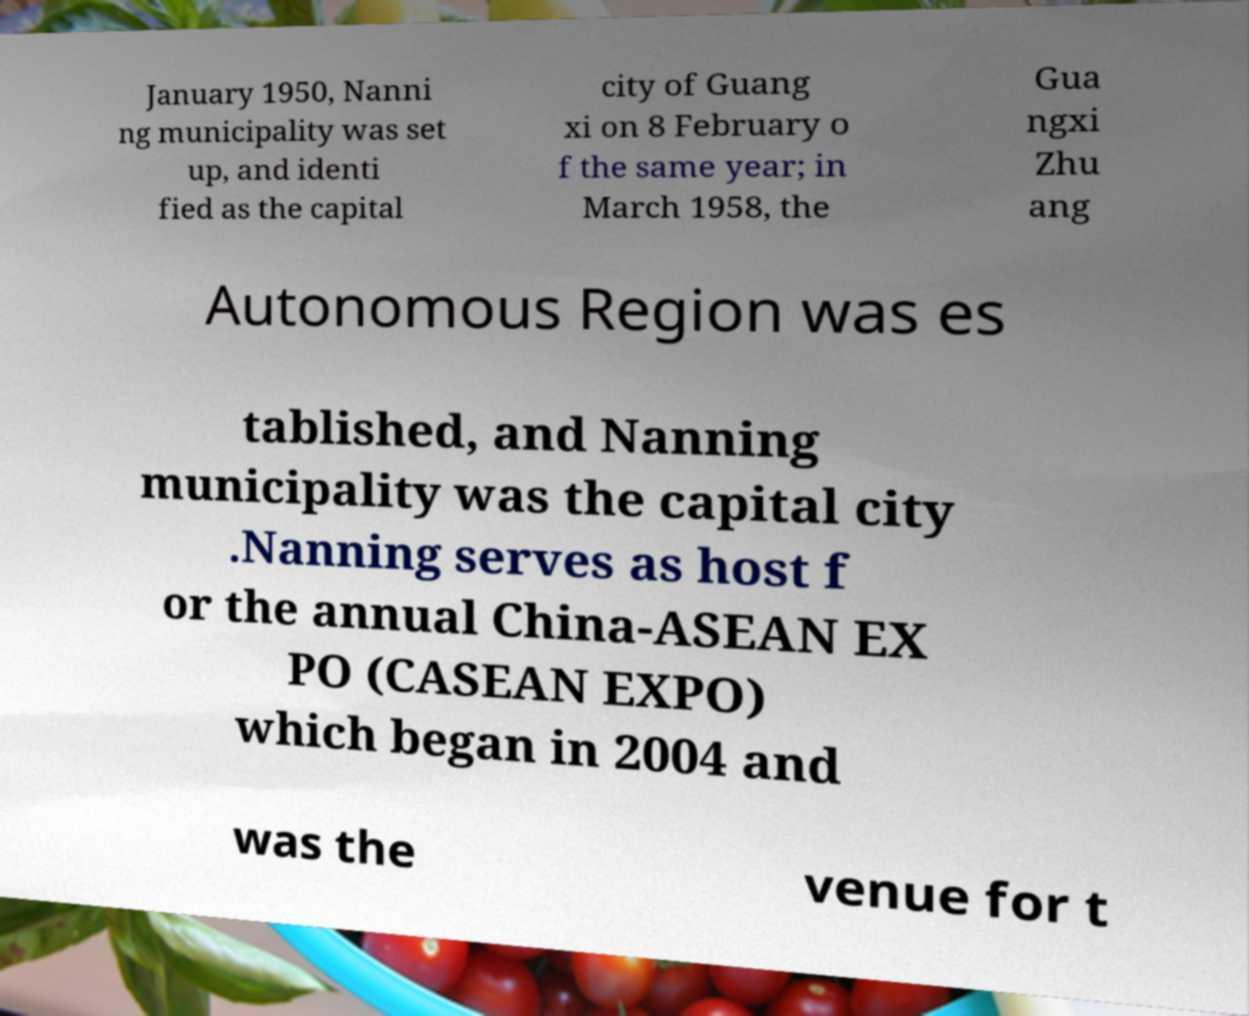There's text embedded in this image that I need extracted. Can you transcribe it verbatim? January 1950, Nanni ng municipality was set up, and identi fied as the capital city of Guang xi on 8 February o f the same year; in March 1958, the Gua ngxi Zhu ang Autonomous Region was es tablished, and Nanning municipality was the capital city .Nanning serves as host f or the annual China-ASEAN EX PO (CASEAN EXPO) which began in 2004 and was the venue for t 